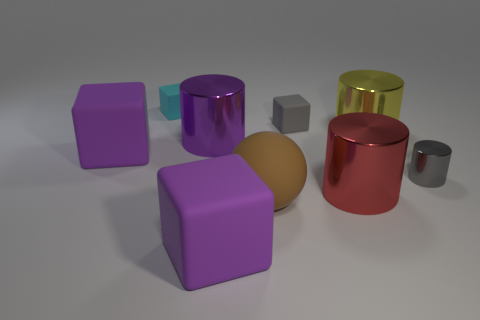Add 1 small blue matte cylinders. How many objects exist? 10 Subtract all balls. How many objects are left? 8 Subtract 0 blue spheres. How many objects are left? 9 Subtract all big matte spheres. Subtract all gray cubes. How many objects are left? 7 Add 3 large rubber objects. How many large rubber objects are left? 6 Add 3 gray shiny cylinders. How many gray shiny cylinders exist? 4 